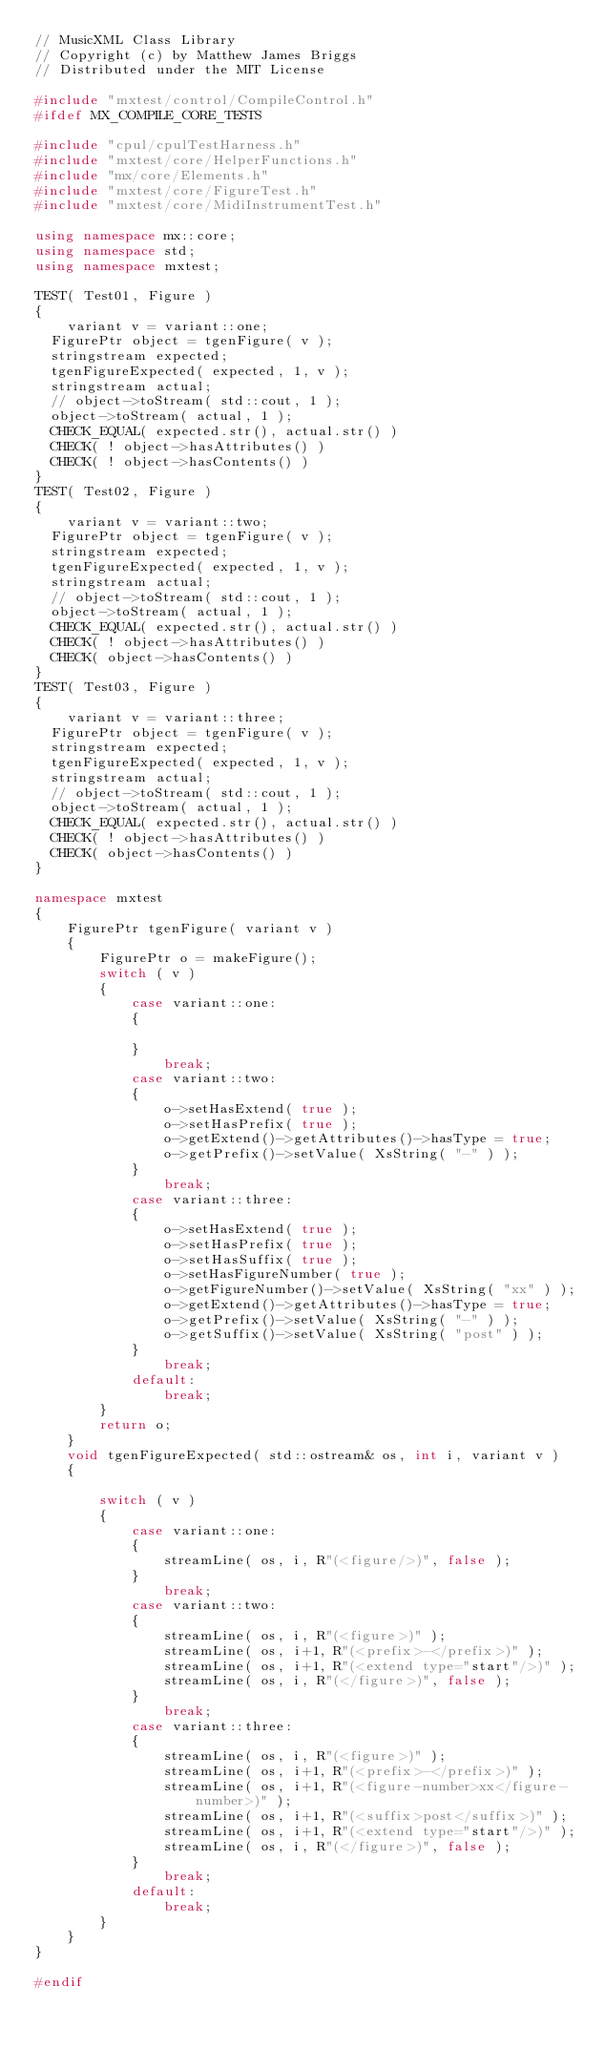Convert code to text. <code><loc_0><loc_0><loc_500><loc_500><_C++_>// MusicXML Class Library
// Copyright (c) by Matthew James Briggs
// Distributed under the MIT License

#include "mxtest/control/CompileControl.h"
#ifdef MX_COMPILE_CORE_TESTS

#include "cpul/cpulTestHarness.h"
#include "mxtest/core/HelperFunctions.h"
#include "mx/core/Elements.h"
#include "mxtest/core/FigureTest.h"
#include "mxtest/core/MidiInstrumentTest.h"

using namespace mx::core;
using namespace std;
using namespace mxtest;

TEST( Test01, Figure )
{
    variant v = variant::one;
	FigurePtr object = tgenFigure( v );
	stringstream expected;
	tgenFigureExpected( expected, 1, v );
	stringstream actual;
	// object->toStream( std::cout, 1 );
	object->toStream( actual, 1 );
	CHECK_EQUAL( expected.str(), actual.str() )
	CHECK( ! object->hasAttributes() )
	CHECK( ! object->hasContents() )
}
TEST( Test02, Figure )
{
    variant v = variant::two;
	FigurePtr object = tgenFigure( v );
	stringstream expected;
	tgenFigureExpected( expected, 1, v );
	stringstream actual;
	// object->toStream( std::cout, 1 );
	object->toStream( actual, 1 );
	CHECK_EQUAL( expected.str(), actual.str() )
	CHECK( ! object->hasAttributes() )
	CHECK( object->hasContents() )
}
TEST( Test03, Figure )
{
    variant v = variant::three;
	FigurePtr object = tgenFigure( v );
	stringstream expected;
	tgenFigureExpected( expected, 1, v );
	stringstream actual;
	// object->toStream( std::cout, 1 );
	object->toStream( actual, 1 );
	CHECK_EQUAL( expected.str(), actual.str() )
	CHECK( ! object->hasAttributes() )
	CHECK( object->hasContents() )
}

namespace mxtest
{
    FigurePtr tgenFigure( variant v )
    {
        FigurePtr o = makeFigure();
        switch ( v )
        {
            case variant::one:
            {
                
            }
                break;
            case variant::two:
            {
                o->setHasExtend( true );
                o->setHasPrefix( true );
                o->getExtend()->getAttributes()->hasType = true;
                o->getPrefix()->setValue( XsString( "-" ) );
            }
                break;
            case variant::three:
            {
                o->setHasExtend( true );
                o->setHasPrefix( true );
                o->setHasSuffix( true );
                o->setHasFigureNumber( true );
                o->getFigureNumber()->setValue( XsString( "xx" ) );
                o->getExtend()->getAttributes()->hasType = true;
                o->getPrefix()->setValue( XsString( "-" ) );
                o->getSuffix()->setValue( XsString( "post" ) );
            }
                break;
            default:
                break;
        }
        return o;
    }
    void tgenFigureExpected( std::ostream& os, int i, variant v )
    {
        
        switch ( v )
        {
            case variant::one:
            {
                streamLine( os, i, R"(<figure/>)", false );
            }
                break;
            case variant::two:
            {
                streamLine( os, i, R"(<figure>)" );
                streamLine( os, i+1, R"(<prefix>-</prefix>)" );
                streamLine( os, i+1, R"(<extend type="start"/>)" );
                streamLine( os, i, R"(</figure>)", false );
            }
                break;
            case variant::three:
            {
                streamLine( os, i, R"(<figure>)" );
                streamLine( os, i+1, R"(<prefix>-</prefix>)" );
                streamLine( os, i+1, R"(<figure-number>xx</figure-number>)" );
                streamLine( os, i+1, R"(<suffix>post</suffix>)" );
                streamLine( os, i+1, R"(<extend type="start"/>)" );
                streamLine( os, i, R"(</figure>)", false );
            }
                break;
            default:
                break;
        }
    }
}

#endif
</code> 